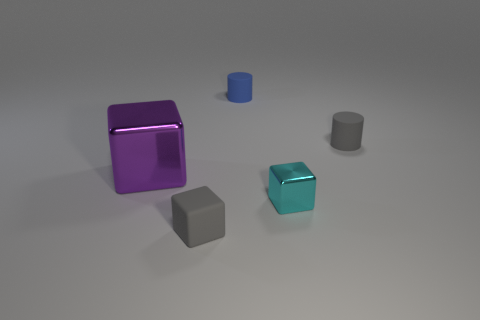Subtract all big metal blocks. How many blocks are left? 2 Add 4 small blue rubber objects. How many objects exist? 9 Subtract 2 cubes. How many cubes are left? 1 Subtract all brown blocks. Subtract all blue cylinders. How many blocks are left? 3 Subtract all blocks. How many objects are left? 2 Add 4 small blue matte objects. How many small blue matte objects exist? 5 Subtract 0 cyan cylinders. How many objects are left? 5 Subtract all green rubber cubes. Subtract all big purple things. How many objects are left? 4 Add 3 big metal objects. How many big metal objects are left? 4 